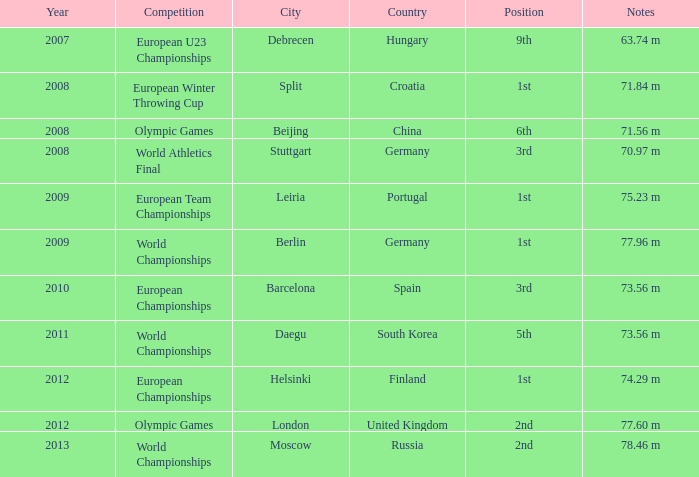Which Notes have a Competition of world championships, and a Position of 2nd? 78.46 m. 